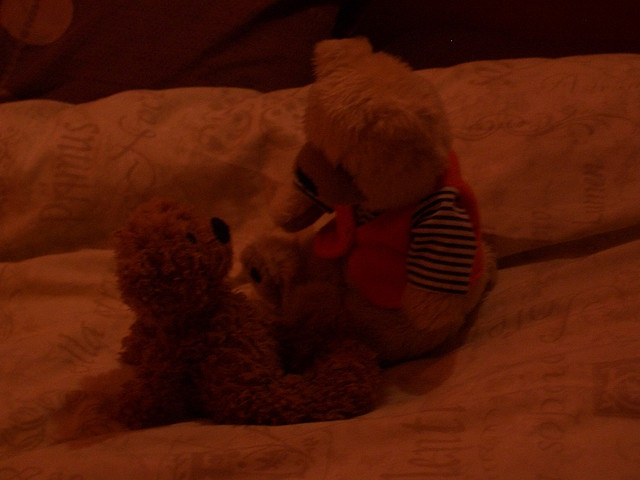Describe the objects in this image and their specific colors. I can see bed in maroon and black tones, teddy bear in maroon and black tones, and teddy bear in maroon and black tones in this image. 